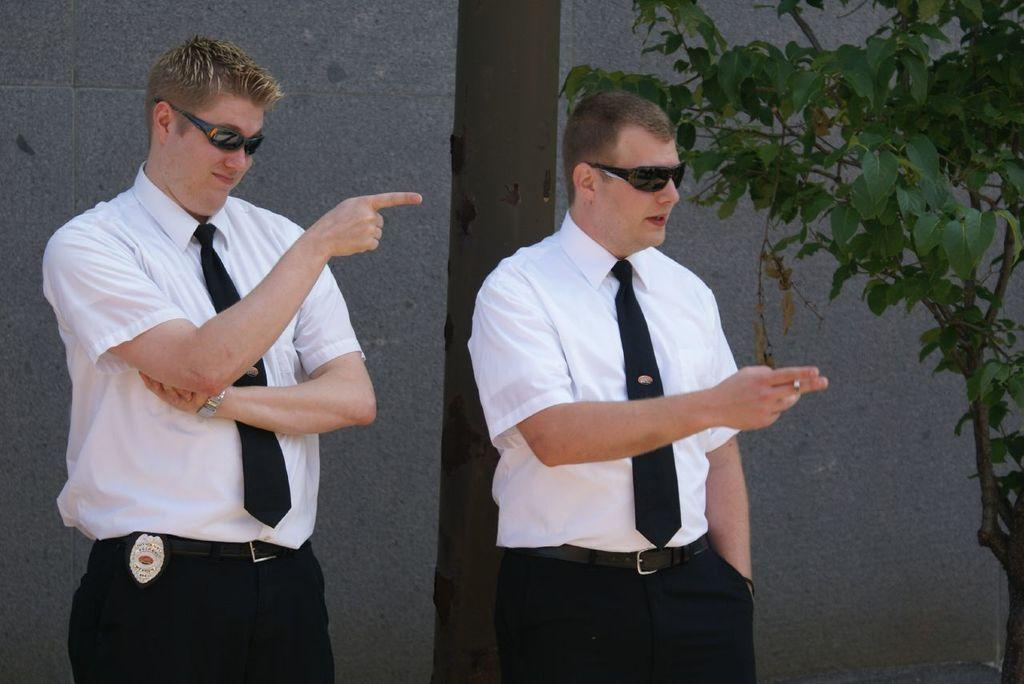What is one of the main features in the image? There is a wall in the image. What other natural element can be seen in the image? There is a tree in the image. How many people are present in the image? There are two people in the image. What color shirts are the two people wearing? The two people are wearing white color shirts. Can you see a crow attempting to play volleyball with the two people in the image? There is no crow or volleyball present in the image. 